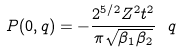<formula> <loc_0><loc_0><loc_500><loc_500>P ( 0 , { q } ) = - \frac { 2 ^ { 5 / 2 } Z ^ { 2 } t ^ { 2 } } { \pi \sqrt { \beta _ { 1 } \beta _ { 2 } } } \ q</formula> 